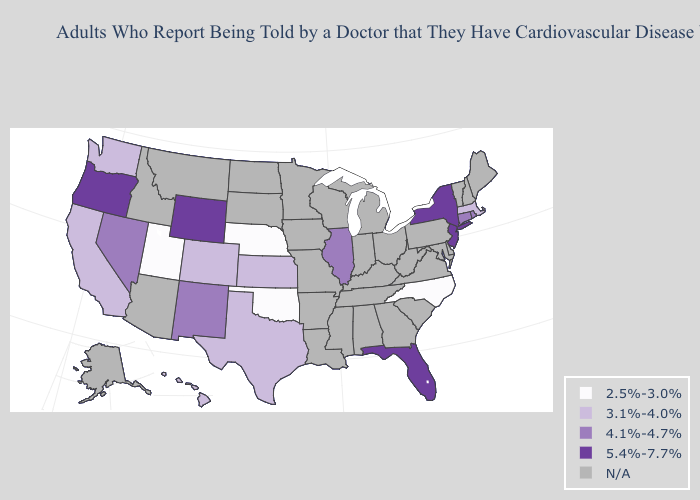Name the states that have a value in the range 2.5%-3.0%?
Give a very brief answer. Nebraska, North Carolina, Oklahoma, Utah. Does Florida have the lowest value in the South?
Short answer required. No. Among the states that border Colorado , does Kansas have the highest value?
Answer briefly. No. Among the states that border Rhode Island , does Connecticut have the highest value?
Answer briefly. Yes. Which states hav the highest value in the Northeast?
Concise answer only. New Jersey, New York. Name the states that have a value in the range 2.5%-3.0%?
Answer briefly. Nebraska, North Carolina, Oklahoma, Utah. Name the states that have a value in the range 3.1%-4.0%?
Quick response, please. California, Colorado, Hawaii, Kansas, Massachusetts, Texas, Washington. Which states have the highest value in the USA?
Be succinct. Florida, New Jersey, New York, Oregon, Wyoming. What is the highest value in the USA?
Give a very brief answer. 5.4%-7.7%. Among the states that border Delaware , which have the lowest value?
Concise answer only. New Jersey. Does Florida have the highest value in the South?
Answer briefly. Yes. Name the states that have a value in the range 4.1%-4.7%?
Give a very brief answer. Connecticut, Illinois, Nevada, New Mexico, Rhode Island. Which states have the lowest value in the USA?
Short answer required. Nebraska, North Carolina, Oklahoma, Utah. Name the states that have a value in the range 3.1%-4.0%?
Short answer required. California, Colorado, Hawaii, Kansas, Massachusetts, Texas, Washington. Which states have the lowest value in the Northeast?
Give a very brief answer. Massachusetts. 